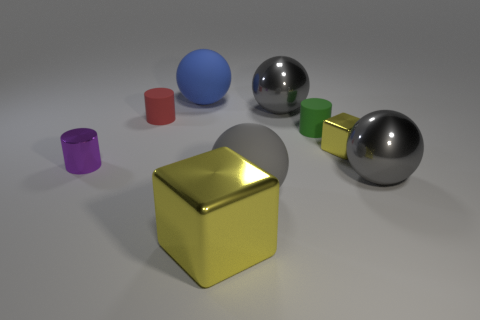There is a cube that is behind the tiny shiny thing to the left of the big block; are there any matte cylinders behind it?
Provide a succinct answer. Yes. There is a big block; is its color the same as the small metallic object to the right of the purple object?
Offer a very short reply. Yes. What number of other cubes have the same color as the tiny block?
Offer a very short reply. 1. What size is the matte cylinder that is behind the cylinder that is to the right of the gray matte object?
Keep it short and to the point. Small. What number of things are large rubber balls that are in front of the small red cylinder or cyan matte cylinders?
Ensure brevity in your answer.  1. Is there a shiny block of the same size as the purple shiny object?
Make the answer very short. Yes. Are there any purple cylinders that are right of the tiny rubber cylinder in front of the small red object?
Keep it short and to the point. No. How many balls are large things or tiny green metal things?
Your response must be concise. 4. Is there another metallic object that has the same shape as the tiny yellow thing?
Ensure brevity in your answer.  Yes. The tiny green matte thing has what shape?
Your answer should be very brief. Cylinder. 